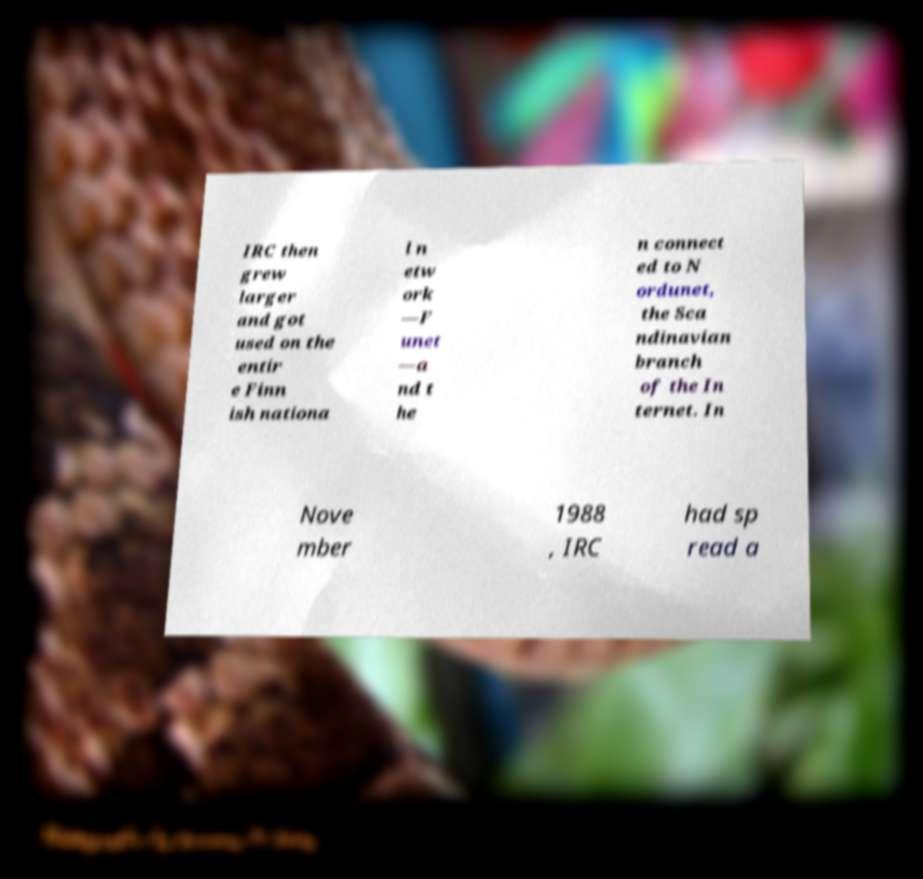For documentation purposes, I need the text within this image transcribed. Could you provide that? IRC then grew larger and got used on the entir e Finn ish nationa l n etw ork —F unet —a nd t he n connect ed to N ordunet, the Sca ndinavian branch of the In ternet. In Nove mber 1988 , IRC had sp read a 